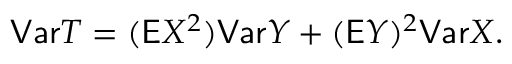Convert formula to latex. <formula><loc_0><loc_0><loc_500><loc_500>V a r T = ( \mathsf E X ^ { 2 } ) V a r Y + ( \mathsf E Y ) ^ { 2 } V a r X .</formula> 